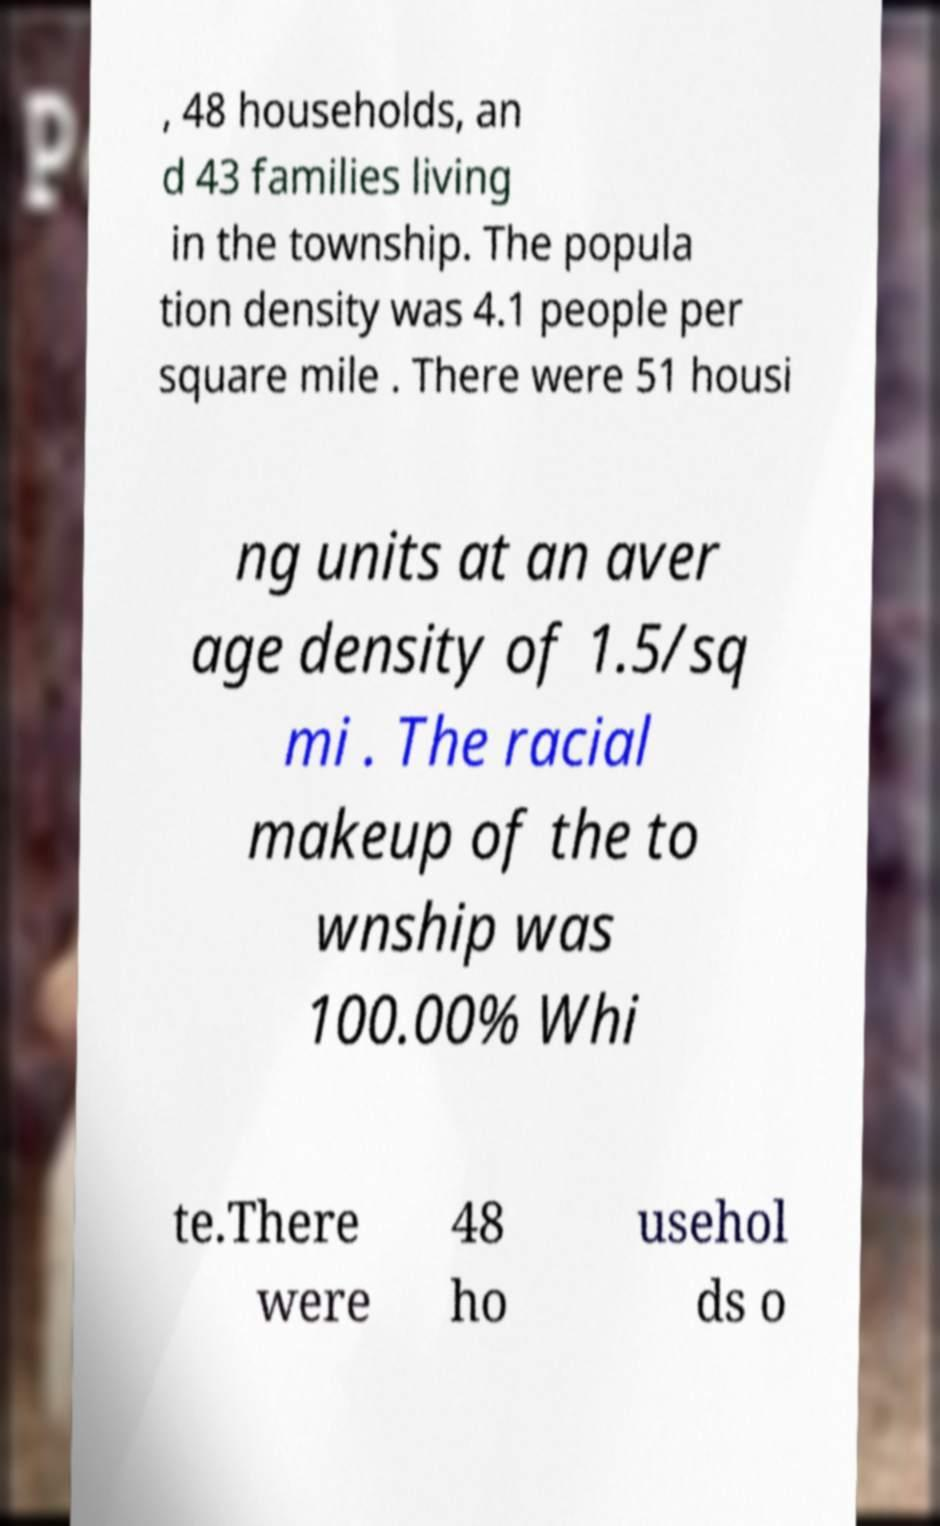I need the written content from this picture converted into text. Can you do that? , 48 households, an d 43 families living in the township. The popula tion density was 4.1 people per square mile . There were 51 housi ng units at an aver age density of 1.5/sq mi . The racial makeup of the to wnship was 100.00% Whi te.There were 48 ho usehol ds o 